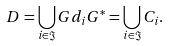<formula> <loc_0><loc_0><loc_500><loc_500>D = \bigcup _ { i \in \Im } G d _ { i } G ^ { * } = \bigcup _ { i \in \Im } C _ { i } .</formula> 